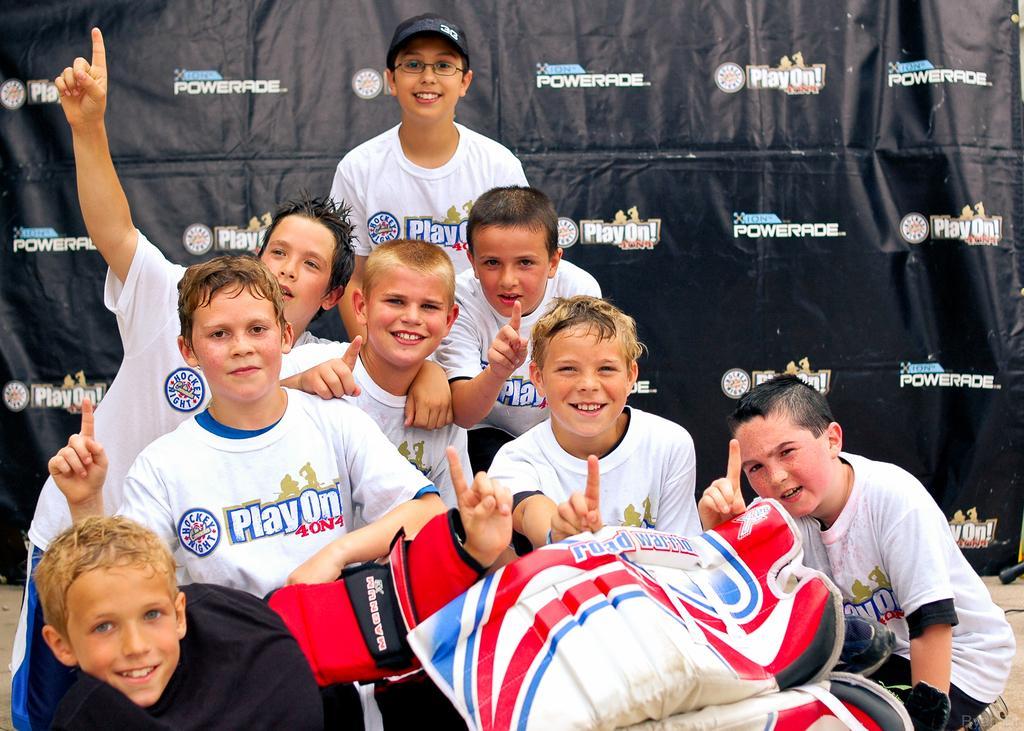Describe this image in one or two sentences. Here we can see a group of children. Background there is a hoarding. 